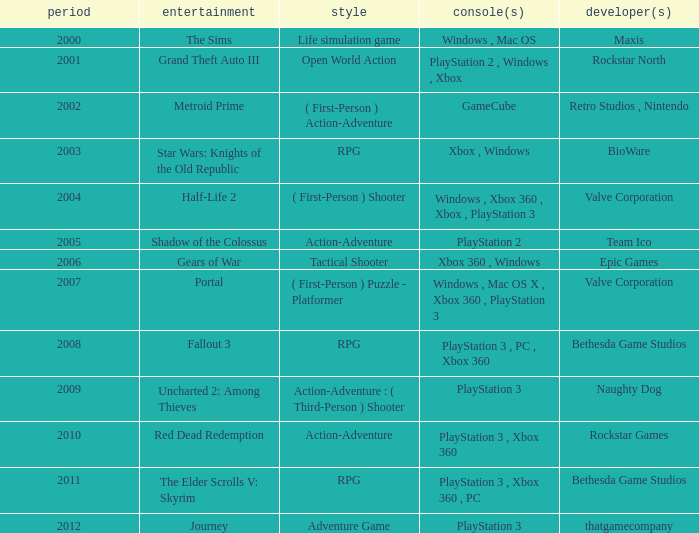What game was in 2011? The Elder Scrolls V: Skyrim. 